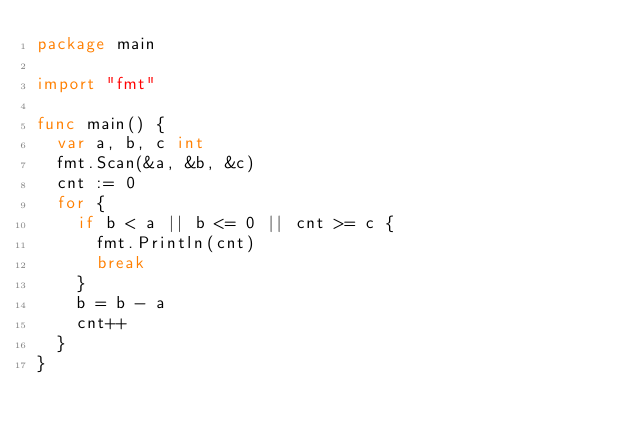<code> <loc_0><loc_0><loc_500><loc_500><_Go_>package main

import "fmt"

func main() {
  var a, b, c int
  fmt.Scan(&a, &b, &c)
  cnt := 0
  for {
    if b < a || b <= 0 || cnt >= c {
      fmt.Println(cnt)
      break
    }
    b = b - a
    cnt++
  }
}</code> 